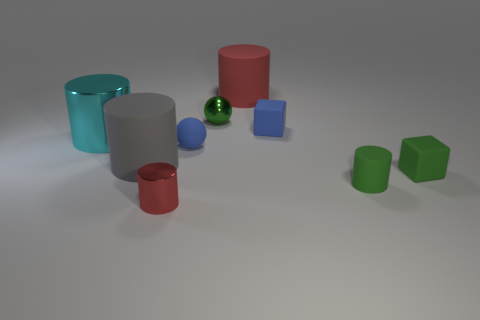What is the size of the green thing that is the same shape as the small red object?
Ensure brevity in your answer.  Small. What number of tiny objects are right of the blue sphere?
Give a very brief answer. 4. There is a matte cylinder that is on the right side of the large red cylinder; is it the same color as the small shiny ball?
Your answer should be very brief. Yes. What number of gray objects are shiny balls or small matte spheres?
Make the answer very short. 0. There is a large matte thing that is in front of the tiny blue object right of the big red matte thing; what is its color?
Offer a terse response. Gray. There is a tiny thing that is the same color as the matte ball; what is its material?
Ensure brevity in your answer.  Rubber. There is a metallic object in front of the green rubber cylinder; what color is it?
Ensure brevity in your answer.  Red. Is the size of the rubber cylinder behind the blue ball the same as the big metallic thing?
Ensure brevity in your answer.  Yes. There is a rubber object that is the same color as the tiny shiny cylinder; what size is it?
Offer a very short reply. Large. Is there a blue matte cube of the same size as the red matte cylinder?
Give a very brief answer. No. 